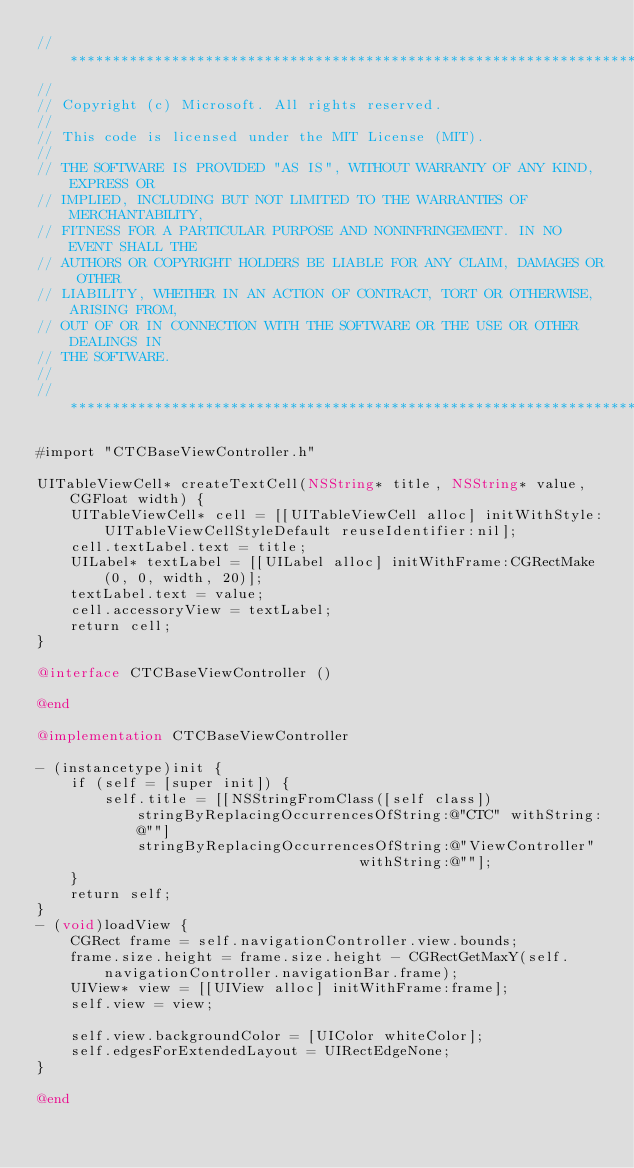<code> <loc_0><loc_0><loc_500><loc_500><_ObjectiveC_>//******************************************************************************
//
// Copyright (c) Microsoft. All rights reserved.
//
// This code is licensed under the MIT License (MIT).
//
// THE SOFTWARE IS PROVIDED "AS IS", WITHOUT WARRANTY OF ANY KIND, EXPRESS OR
// IMPLIED, INCLUDING BUT NOT LIMITED TO THE WARRANTIES OF MERCHANTABILITY,
// FITNESS FOR A PARTICULAR PURPOSE AND NONINFRINGEMENT. IN NO EVENT SHALL THE
// AUTHORS OR COPYRIGHT HOLDERS BE LIABLE FOR ANY CLAIM, DAMAGES OR OTHER
// LIABILITY, WHETHER IN AN ACTION OF CONTRACT, TORT OR OTHERWISE, ARISING FROM,
// OUT OF OR IN CONNECTION WITH THE SOFTWARE OR THE USE OR OTHER DEALINGS IN
// THE SOFTWARE.
//
//*****************************************************************************

#import "CTCBaseViewController.h"

UITableViewCell* createTextCell(NSString* title, NSString* value, CGFloat width) {
    UITableViewCell* cell = [[UITableViewCell alloc] initWithStyle:UITableViewCellStyleDefault reuseIdentifier:nil];
    cell.textLabel.text = title;
    UILabel* textLabel = [[UILabel alloc] initWithFrame:CGRectMake(0, 0, width, 20)];
    textLabel.text = value;
    cell.accessoryView = textLabel;
    return cell;
}

@interface CTCBaseViewController ()

@end

@implementation CTCBaseViewController

- (instancetype)init {
    if (self = [super init]) {
        self.title = [[NSStringFromClass([self class]) stringByReplacingOccurrencesOfString:@"CTC" withString:@""]
            stringByReplacingOccurrencesOfString:@"ViewController"
                                      withString:@""];
    }
    return self;
}
- (void)loadView {
    CGRect frame = self.navigationController.view.bounds;
    frame.size.height = frame.size.height - CGRectGetMaxY(self.navigationController.navigationBar.frame);
    UIView* view = [[UIView alloc] initWithFrame:frame];
    self.view = view;

    self.view.backgroundColor = [UIColor whiteColor];
    self.edgesForExtendedLayout = UIRectEdgeNone;
}

@end
</code> 